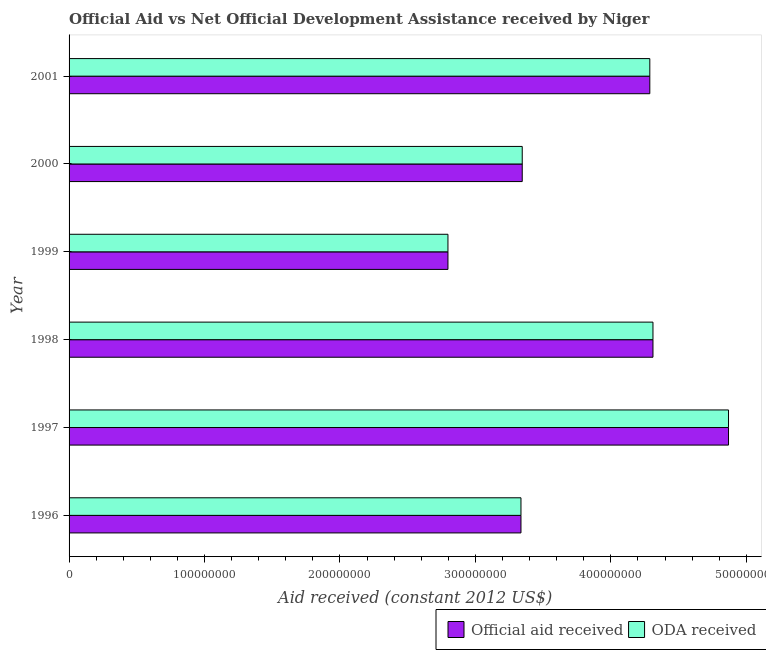Are the number of bars per tick equal to the number of legend labels?
Ensure brevity in your answer.  Yes. What is the official aid received in 1999?
Give a very brief answer. 2.80e+08. Across all years, what is the maximum official aid received?
Offer a terse response. 4.87e+08. Across all years, what is the minimum official aid received?
Your answer should be very brief. 2.80e+08. In which year was the official aid received minimum?
Make the answer very short. 1999. What is the total oda received in the graph?
Your answer should be compact. 2.29e+09. What is the difference between the oda received in 1996 and that in 1997?
Provide a succinct answer. -1.53e+08. What is the difference between the official aid received in 1997 and the oda received in 2000?
Your response must be concise. 1.52e+08. What is the average oda received per year?
Ensure brevity in your answer.  3.82e+08. In the year 2000, what is the difference between the oda received and official aid received?
Keep it short and to the point. 0. In how many years, is the oda received greater than 480000000 US$?
Your answer should be compact. 1. What is the ratio of the oda received in 1996 to that in 1998?
Provide a short and direct response. 0.77. Is the difference between the official aid received in 1996 and 2001 greater than the difference between the oda received in 1996 and 2001?
Your answer should be very brief. No. What is the difference between the highest and the second highest official aid received?
Offer a terse response. 5.58e+07. What is the difference between the highest and the lowest official aid received?
Offer a terse response. 2.07e+08. Is the sum of the official aid received in 1996 and 2001 greater than the maximum oda received across all years?
Offer a terse response. Yes. What does the 1st bar from the top in 1996 represents?
Your response must be concise. ODA received. What does the 2nd bar from the bottom in 1997 represents?
Keep it short and to the point. ODA received. How many years are there in the graph?
Give a very brief answer. 6. What is the difference between two consecutive major ticks on the X-axis?
Give a very brief answer. 1.00e+08. Does the graph contain any zero values?
Give a very brief answer. No. Where does the legend appear in the graph?
Your response must be concise. Bottom right. How are the legend labels stacked?
Your answer should be very brief. Horizontal. What is the title of the graph?
Ensure brevity in your answer.  Official Aid vs Net Official Development Assistance received by Niger . Does "Investment in Telecom" appear as one of the legend labels in the graph?
Ensure brevity in your answer.  No. What is the label or title of the X-axis?
Keep it short and to the point. Aid received (constant 2012 US$). What is the label or title of the Y-axis?
Keep it short and to the point. Year. What is the Aid received (constant 2012 US$) of Official aid received in 1996?
Provide a succinct answer. 3.34e+08. What is the Aid received (constant 2012 US$) in ODA received in 1996?
Offer a terse response. 3.34e+08. What is the Aid received (constant 2012 US$) in Official aid received in 1997?
Provide a short and direct response. 4.87e+08. What is the Aid received (constant 2012 US$) of ODA received in 1997?
Keep it short and to the point. 4.87e+08. What is the Aid received (constant 2012 US$) in Official aid received in 1998?
Give a very brief answer. 4.31e+08. What is the Aid received (constant 2012 US$) of ODA received in 1998?
Your response must be concise. 4.31e+08. What is the Aid received (constant 2012 US$) of Official aid received in 1999?
Provide a succinct answer. 2.80e+08. What is the Aid received (constant 2012 US$) of ODA received in 1999?
Your response must be concise. 2.80e+08. What is the Aid received (constant 2012 US$) in Official aid received in 2000?
Your answer should be very brief. 3.35e+08. What is the Aid received (constant 2012 US$) of ODA received in 2000?
Ensure brevity in your answer.  3.35e+08. What is the Aid received (constant 2012 US$) in Official aid received in 2001?
Your answer should be compact. 4.29e+08. What is the Aid received (constant 2012 US$) in ODA received in 2001?
Ensure brevity in your answer.  4.29e+08. Across all years, what is the maximum Aid received (constant 2012 US$) in Official aid received?
Offer a terse response. 4.87e+08. Across all years, what is the maximum Aid received (constant 2012 US$) of ODA received?
Your response must be concise. 4.87e+08. Across all years, what is the minimum Aid received (constant 2012 US$) in Official aid received?
Your answer should be compact. 2.80e+08. Across all years, what is the minimum Aid received (constant 2012 US$) of ODA received?
Provide a succinct answer. 2.80e+08. What is the total Aid received (constant 2012 US$) of Official aid received in the graph?
Ensure brevity in your answer.  2.29e+09. What is the total Aid received (constant 2012 US$) of ODA received in the graph?
Make the answer very short. 2.29e+09. What is the difference between the Aid received (constant 2012 US$) of Official aid received in 1996 and that in 1997?
Offer a terse response. -1.53e+08. What is the difference between the Aid received (constant 2012 US$) of ODA received in 1996 and that in 1997?
Make the answer very short. -1.53e+08. What is the difference between the Aid received (constant 2012 US$) of Official aid received in 1996 and that in 1998?
Offer a terse response. -9.74e+07. What is the difference between the Aid received (constant 2012 US$) in ODA received in 1996 and that in 1998?
Keep it short and to the point. -9.74e+07. What is the difference between the Aid received (constant 2012 US$) of Official aid received in 1996 and that in 1999?
Your answer should be compact. 5.39e+07. What is the difference between the Aid received (constant 2012 US$) of ODA received in 1996 and that in 1999?
Ensure brevity in your answer.  5.39e+07. What is the difference between the Aid received (constant 2012 US$) in Official aid received in 1996 and that in 2000?
Your answer should be very brief. -9.40e+05. What is the difference between the Aid received (constant 2012 US$) in ODA received in 1996 and that in 2000?
Provide a short and direct response. -9.40e+05. What is the difference between the Aid received (constant 2012 US$) in Official aid received in 1996 and that in 2001?
Offer a very short reply. -9.51e+07. What is the difference between the Aid received (constant 2012 US$) of ODA received in 1996 and that in 2001?
Ensure brevity in your answer.  -9.51e+07. What is the difference between the Aid received (constant 2012 US$) of Official aid received in 1997 and that in 1998?
Offer a terse response. 5.58e+07. What is the difference between the Aid received (constant 2012 US$) of ODA received in 1997 and that in 1998?
Make the answer very short. 5.58e+07. What is the difference between the Aid received (constant 2012 US$) of Official aid received in 1997 and that in 1999?
Your answer should be compact. 2.07e+08. What is the difference between the Aid received (constant 2012 US$) in ODA received in 1997 and that in 1999?
Give a very brief answer. 2.07e+08. What is the difference between the Aid received (constant 2012 US$) of Official aid received in 1997 and that in 2000?
Your answer should be compact. 1.52e+08. What is the difference between the Aid received (constant 2012 US$) of ODA received in 1997 and that in 2000?
Provide a short and direct response. 1.52e+08. What is the difference between the Aid received (constant 2012 US$) in Official aid received in 1997 and that in 2001?
Keep it short and to the point. 5.81e+07. What is the difference between the Aid received (constant 2012 US$) in ODA received in 1997 and that in 2001?
Provide a short and direct response. 5.81e+07. What is the difference between the Aid received (constant 2012 US$) of Official aid received in 1998 and that in 1999?
Keep it short and to the point. 1.51e+08. What is the difference between the Aid received (constant 2012 US$) in ODA received in 1998 and that in 1999?
Your response must be concise. 1.51e+08. What is the difference between the Aid received (constant 2012 US$) in Official aid received in 1998 and that in 2000?
Keep it short and to the point. 9.65e+07. What is the difference between the Aid received (constant 2012 US$) of ODA received in 1998 and that in 2000?
Keep it short and to the point. 9.65e+07. What is the difference between the Aid received (constant 2012 US$) of Official aid received in 1998 and that in 2001?
Offer a very short reply. 2.33e+06. What is the difference between the Aid received (constant 2012 US$) of ODA received in 1998 and that in 2001?
Keep it short and to the point. 2.33e+06. What is the difference between the Aid received (constant 2012 US$) of Official aid received in 1999 and that in 2000?
Offer a very short reply. -5.48e+07. What is the difference between the Aid received (constant 2012 US$) of ODA received in 1999 and that in 2000?
Make the answer very short. -5.48e+07. What is the difference between the Aid received (constant 2012 US$) in Official aid received in 1999 and that in 2001?
Ensure brevity in your answer.  -1.49e+08. What is the difference between the Aid received (constant 2012 US$) of ODA received in 1999 and that in 2001?
Your answer should be very brief. -1.49e+08. What is the difference between the Aid received (constant 2012 US$) of Official aid received in 2000 and that in 2001?
Provide a short and direct response. -9.42e+07. What is the difference between the Aid received (constant 2012 US$) of ODA received in 2000 and that in 2001?
Offer a very short reply. -9.42e+07. What is the difference between the Aid received (constant 2012 US$) of Official aid received in 1996 and the Aid received (constant 2012 US$) of ODA received in 1997?
Keep it short and to the point. -1.53e+08. What is the difference between the Aid received (constant 2012 US$) in Official aid received in 1996 and the Aid received (constant 2012 US$) in ODA received in 1998?
Keep it short and to the point. -9.74e+07. What is the difference between the Aid received (constant 2012 US$) in Official aid received in 1996 and the Aid received (constant 2012 US$) in ODA received in 1999?
Offer a very short reply. 5.39e+07. What is the difference between the Aid received (constant 2012 US$) of Official aid received in 1996 and the Aid received (constant 2012 US$) of ODA received in 2000?
Ensure brevity in your answer.  -9.40e+05. What is the difference between the Aid received (constant 2012 US$) in Official aid received in 1996 and the Aid received (constant 2012 US$) in ODA received in 2001?
Give a very brief answer. -9.51e+07. What is the difference between the Aid received (constant 2012 US$) in Official aid received in 1997 and the Aid received (constant 2012 US$) in ODA received in 1998?
Your answer should be very brief. 5.58e+07. What is the difference between the Aid received (constant 2012 US$) of Official aid received in 1997 and the Aid received (constant 2012 US$) of ODA received in 1999?
Your answer should be compact. 2.07e+08. What is the difference between the Aid received (constant 2012 US$) in Official aid received in 1997 and the Aid received (constant 2012 US$) in ODA received in 2000?
Your response must be concise. 1.52e+08. What is the difference between the Aid received (constant 2012 US$) of Official aid received in 1997 and the Aid received (constant 2012 US$) of ODA received in 2001?
Keep it short and to the point. 5.81e+07. What is the difference between the Aid received (constant 2012 US$) of Official aid received in 1998 and the Aid received (constant 2012 US$) of ODA received in 1999?
Offer a very short reply. 1.51e+08. What is the difference between the Aid received (constant 2012 US$) of Official aid received in 1998 and the Aid received (constant 2012 US$) of ODA received in 2000?
Your response must be concise. 9.65e+07. What is the difference between the Aid received (constant 2012 US$) of Official aid received in 1998 and the Aid received (constant 2012 US$) of ODA received in 2001?
Ensure brevity in your answer.  2.33e+06. What is the difference between the Aid received (constant 2012 US$) in Official aid received in 1999 and the Aid received (constant 2012 US$) in ODA received in 2000?
Ensure brevity in your answer.  -5.48e+07. What is the difference between the Aid received (constant 2012 US$) in Official aid received in 1999 and the Aid received (constant 2012 US$) in ODA received in 2001?
Keep it short and to the point. -1.49e+08. What is the difference between the Aid received (constant 2012 US$) in Official aid received in 2000 and the Aid received (constant 2012 US$) in ODA received in 2001?
Your response must be concise. -9.42e+07. What is the average Aid received (constant 2012 US$) in Official aid received per year?
Ensure brevity in your answer.  3.82e+08. What is the average Aid received (constant 2012 US$) of ODA received per year?
Make the answer very short. 3.82e+08. In the year 1996, what is the difference between the Aid received (constant 2012 US$) in Official aid received and Aid received (constant 2012 US$) in ODA received?
Provide a short and direct response. 0. In the year 1997, what is the difference between the Aid received (constant 2012 US$) in Official aid received and Aid received (constant 2012 US$) in ODA received?
Provide a short and direct response. 0. In the year 2000, what is the difference between the Aid received (constant 2012 US$) of Official aid received and Aid received (constant 2012 US$) of ODA received?
Keep it short and to the point. 0. In the year 2001, what is the difference between the Aid received (constant 2012 US$) of Official aid received and Aid received (constant 2012 US$) of ODA received?
Ensure brevity in your answer.  0. What is the ratio of the Aid received (constant 2012 US$) of Official aid received in 1996 to that in 1997?
Make the answer very short. 0.69. What is the ratio of the Aid received (constant 2012 US$) of ODA received in 1996 to that in 1997?
Your response must be concise. 0.69. What is the ratio of the Aid received (constant 2012 US$) in Official aid received in 1996 to that in 1998?
Offer a terse response. 0.77. What is the ratio of the Aid received (constant 2012 US$) in ODA received in 1996 to that in 1998?
Your answer should be very brief. 0.77. What is the ratio of the Aid received (constant 2012 US$) of Official aid received in 1996 to that in 1999?
Ensure brevity in your answer.  1.19. What is the ratio of the Aid received (constant 2012 US$) of ODA received in 1996 to that in 1999?
Provide a succinct answer. 1.19. What is the ratio of the Aid received (constant 2012 US$) of Official aid received in 1996 to that in 2001?
Make the answer very short. 0.78. What is the ratio of the Aid received (constant 2012 US$) in ODA received in 1996 to that in 2001?
Ensure brevity in your answer.  0.78. What is the ratio of the Aid received (constant 2012 US$) in Official aid received in 1997 to that in 1998?
Ensure brevity in your answer.  1.13. What is the ratio of the Aid received (constant 2012 US$) of ODA received in 1997 to that in 1998?
Ensure brevity in your answer.  1.13. What is the ratio of the Aid received (constant 2012 US$) of Official aid received in 1997 to that in 1999?
Your answer should be very brief. 1.74. What is the ratio of the Aid received (constant 2012 US$) in ODA received in 1997 to that in 1999?
Provide a succinct answer. 1.74. What is the ratio of the Aid received (constant 2012 US$) in Official aid received in 1997 to that in 2000?
Your answer should be compact. 1.46. What is the ratio of the Aid received (constant 2012 US$) in ODA received in 1997 to that in 2000?
Keep it short and to the point. 1.46. What is the ratio of the Aid received (constant 2012 US$) in Official aid received in 1997 to that in 2001?
Provide a succinct answer. 1.14. What is the ratio of the Aid received (constant 2012 US$) in ODA received in 1997 to that in 2001?
Provide a short and direct response. 1.14. What is the ratio of the Aid received (constant 2012 US$) in Official aid received in 1998 to that in 1999?
Ensure brevity in your answer.  1.54. What is the ratio of the Aid received (constant 2012 US$) of ODA received in 1998 to that in 1999?
Your answer should be compact. 1.54. What is the ratio of the Aid received (constant 2012 US$) of Official aid received in 1998 to that in 2000?
Your response must be concise. 1.29. What is the ratio of the Aid received (constant 2012 US$) of ODA received in 1998 to that in 2000?
Offer a very short reply. 1.29. What is the ratio of the Aid received (constant 2012 US$) in Official aid received in 1998 to that in 2001?
Your response must be concise. 1.01. What is the ratio of the Aid received (constant 2012 US$) of ODA received in 1998 to that in 2001?
Your answer should be very brief. 1.01. What is the ratio of the Aid received (constant 2012 US$) in Official aid received in 1999 to that in 2000?
Make the answer very short. 0.84. What is the ratio of the Aid received (constant 2012 US$) in ODA received in 1999 to that in 2000?
Your answer should be very brief. 0.84. What is the ratio of the Aid received (constant 2012 US$) in Official aid received in 1999 to that in 2001?
Keep it short and to the point. 0.65. What is the ratio of the Aid received (constant 2012 US$) of ODA received in 1999 to that in 2001?
Your answer should be compact. 0.65. What is the ratio of the Aid received (constant 2012 US$) in Official aid received in 2000 to that in 2001?
Provide a short and direct response. 0.78. What is the ratio of the Aid received (constant 2012 US$) in ODA received in 2000 to that in 2001?
Keep it short and to the point. 0.78. What is the difference between the highest and the second highest Aid received (constant 2012 US$) in Official aid received?
Make the answer very short. 5.58e+07. What is the difference between the highest and the second highest Aid received (constant 2012 US$) in ODA received?
Ensure brevity in your answer.  5.58e+07. What is the difference between the highest and the lowest Aid received (constant 2012 US$) in Official aid received?
Ensure brevity in your answer.  2.07e+08. What is the difference between the highest and the lowest Aid received (constant 2012 US$) in ODA received?
Provide a succinct answer. 2.07e+08. 